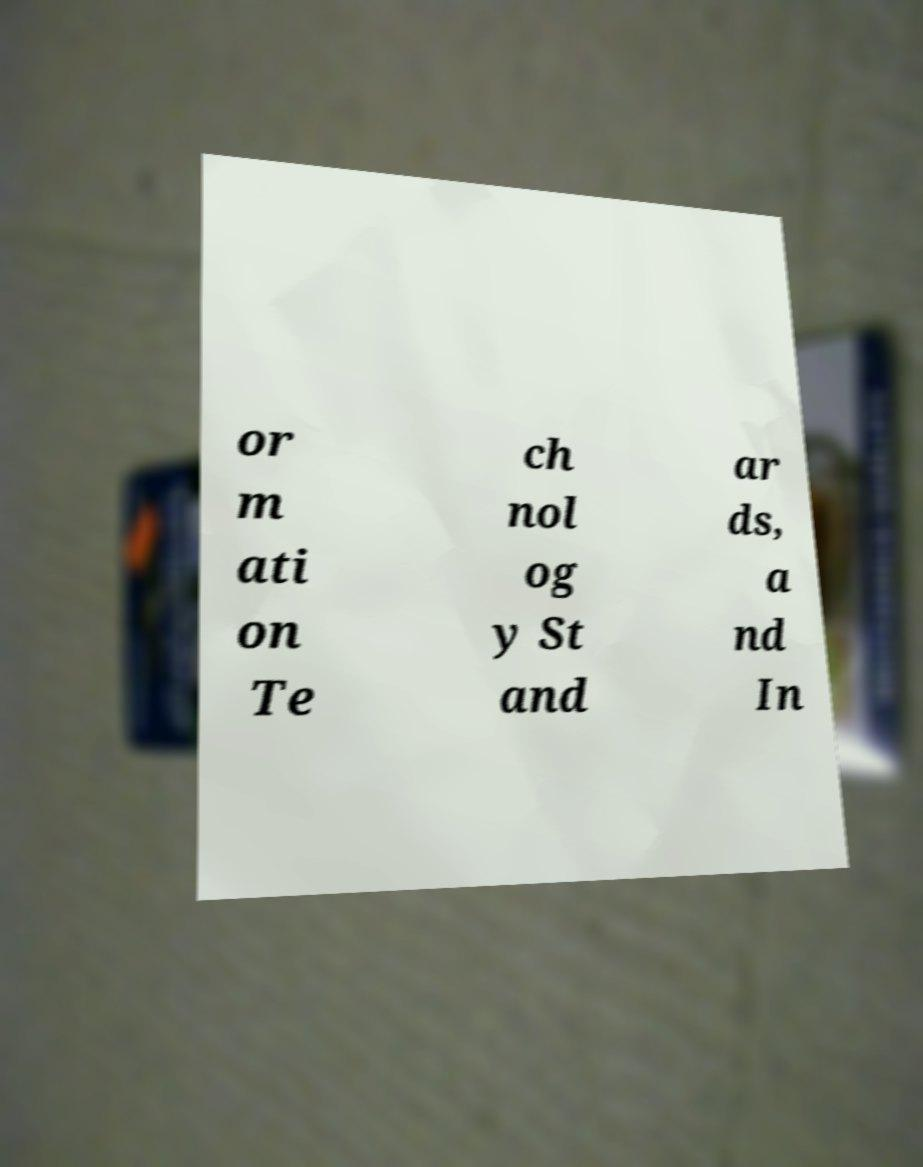Please read and relay the text visible in this image. What does it say? or m ati on Te ch nol og y St and ar ds, a nd In 